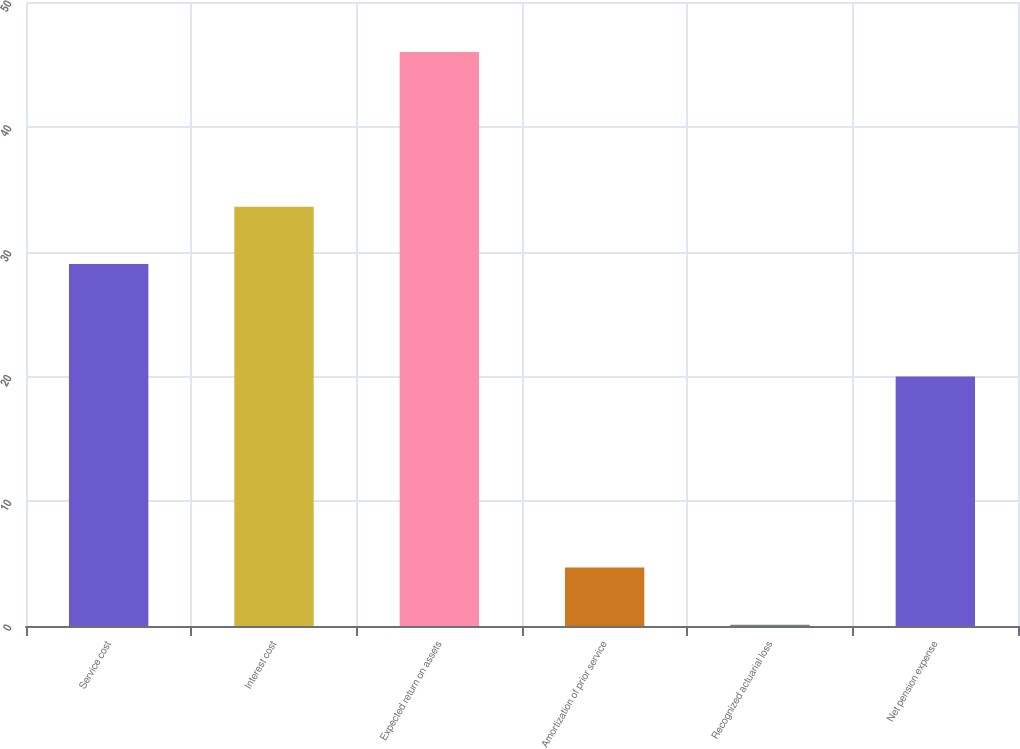Convert chart. <chart><loc_0><loc_0><loc_500><loc_500><bar_chart><fcel>Service cost<fcel>Interest cost<fcel>Expected return on assets<fcel>Amortization of prior service<fcel>Recognized actuarial loss<fcel>Net pension expense<nl><fcel>29<fcel>33.59<fcel>46<fcel>4.69<fcel>0.1<fcel>20<nl></chart> 